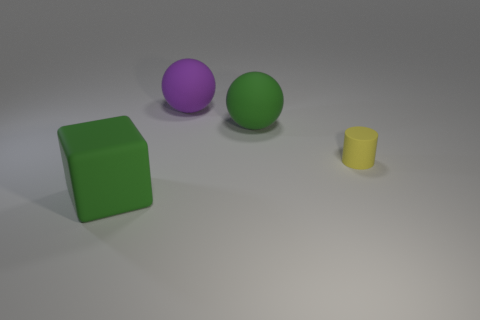Add 4 small blue shiny objects. How many objects exist? 8 Subtract all cubes. How many objects are left? 3 Subtract 0 brown cylinders. How many objects are left? 4 Subtract all large green matte spheres. Subtract all green objects. How many objects are left? 1 Add 4 green rubber objects. How many green rubber objects are left? 6 Add 2 tiny green cylinders. How many tiny green cylinders exist? 2 